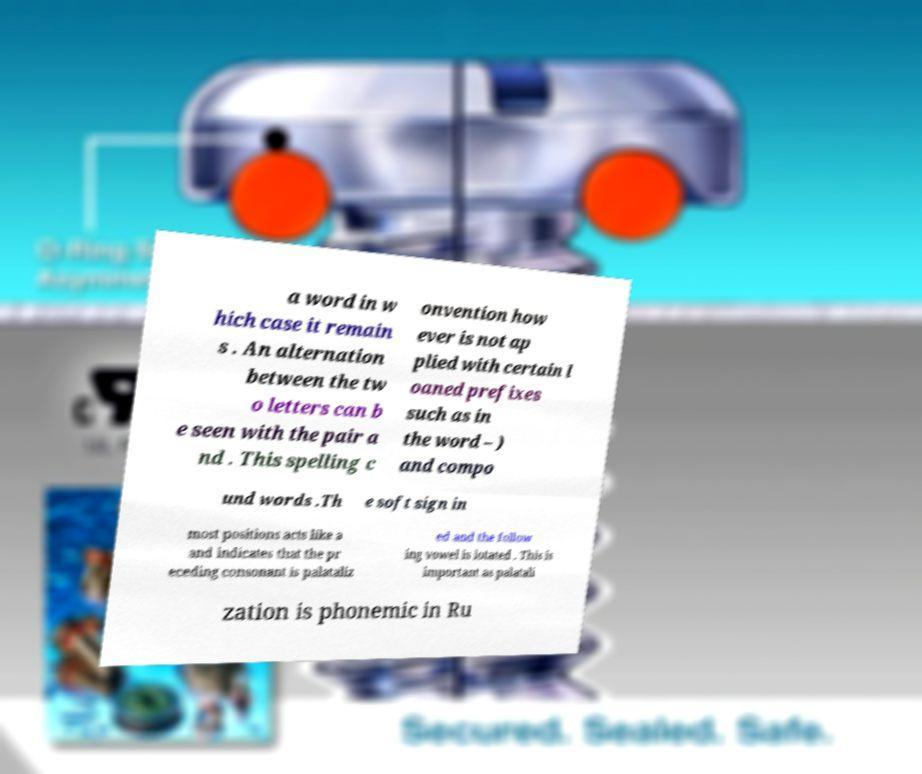There's text embedded in this image that I need extracted. Can you transcribe it verbatim? a word in w hich case it remain s . An alternation between the tw o letters can b e seen with the pair a nd . This spelling c onvention how ever is not ap plied with certain l oaned prefixes such as in the word – ) and compo und words .Th e soft sign in most positions acts like a and indicates that the pr eceding consonant is palataliz ed and the follow ing vowel is iotated . This is important as palatali zation is phonemic in Ru 